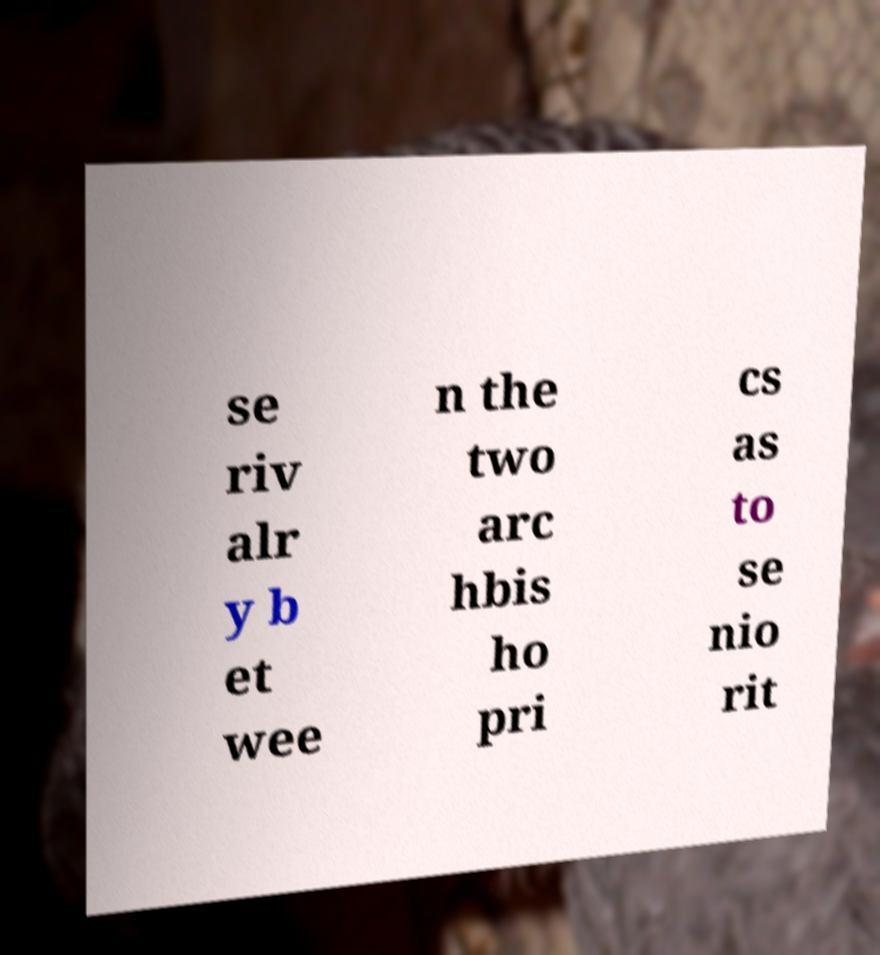Please read and relay the text visible in this image. What does it say? se riv alr y b et wee n the two arc hbis ho pri cs as to se nio rit 